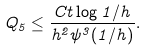<formula> <loc_0><loc_0><loc_500><loc_500>Q _ { 5 } \leq \frac { C t \log 1 / h } { h ^ { 2 } \psi ^ { 3 } ( 1 / h ) } .</formula> 